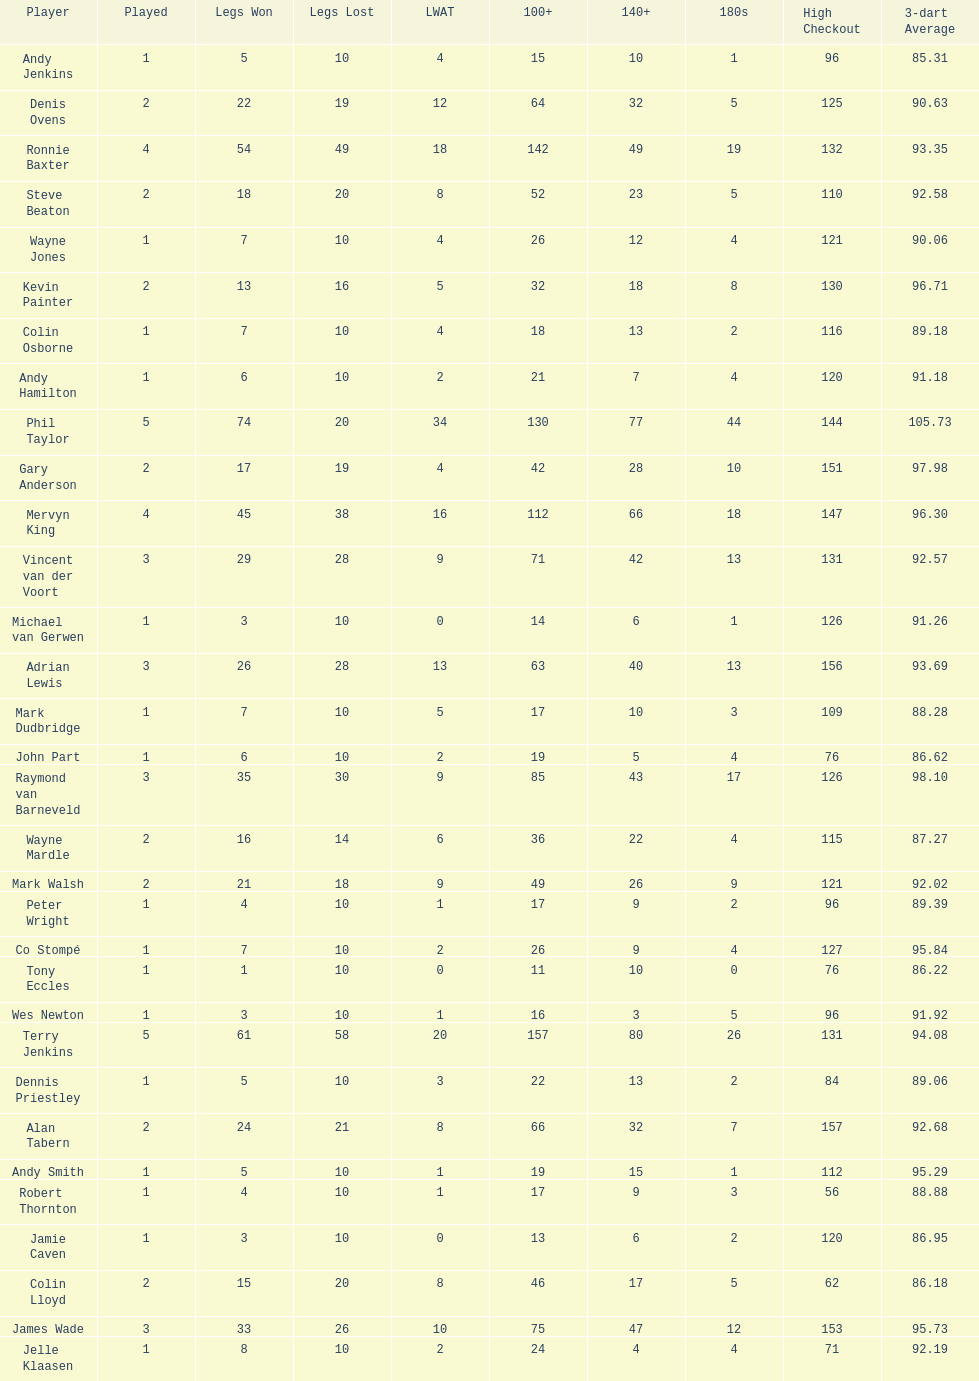What is the total amount of players who played more than 3 games? 4. 